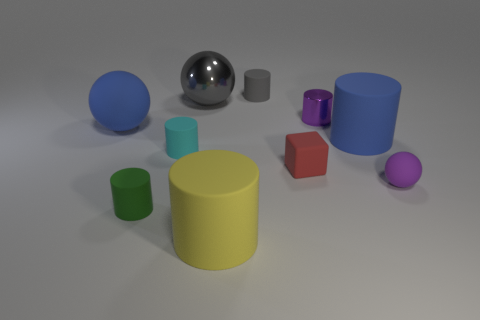What materials seem to have been used in the objects depicted in the image? The objects in the image appear to have a variety of simulated materials. Some have a shiny, reflective surface that could be reminiscent of metal or plastic, while others possess a matte finish that might suggest a clay or rubber-like material in real life. The diversity in texture and finish helps distinguish the objects from each other. 